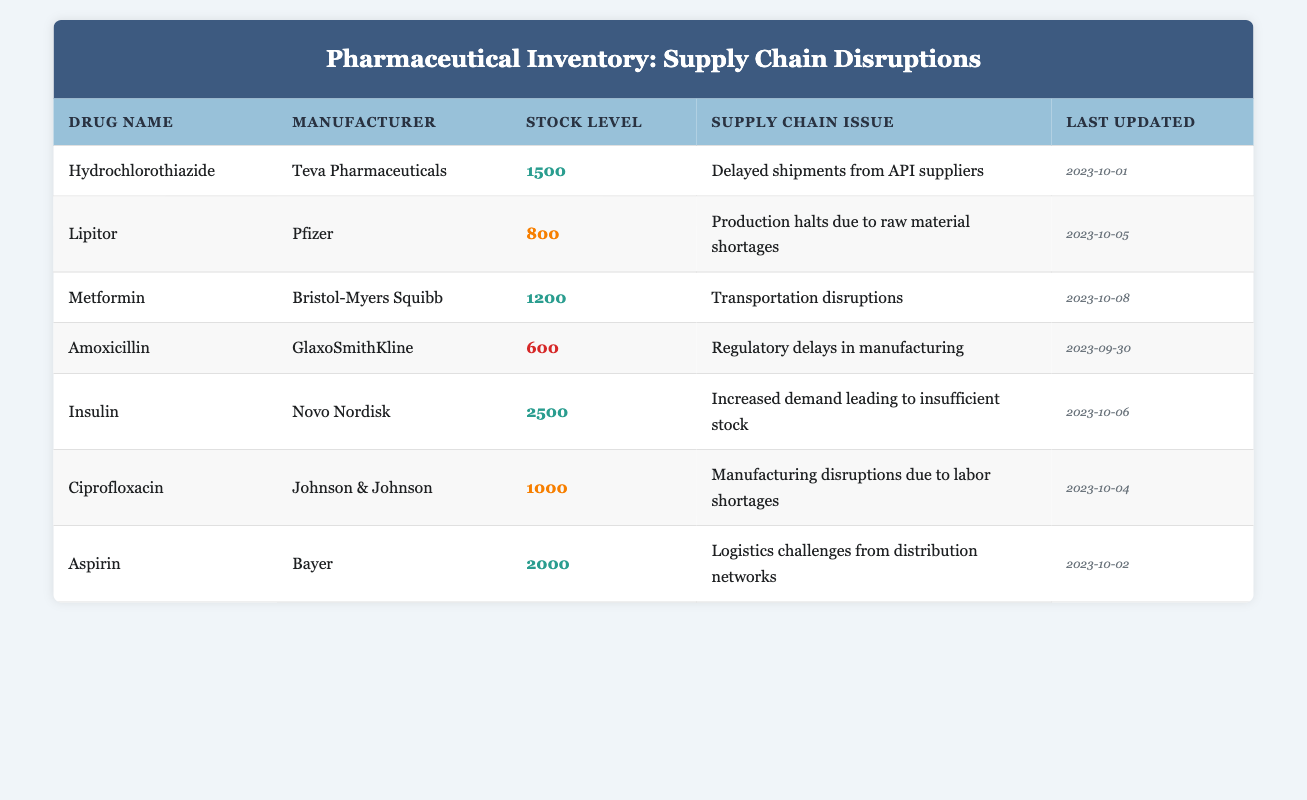What is the stock level of Metformin? The stock level of Metformin is listed in the "Stock Level" column next to the drug name "Metformin". It shows the value 1200.
Answer: 1200 Which drug has the lowest stock level? Looking through the "Stock Level" column, Amoxicillin has the lowest stock level of 600, as it's the smallest value in that column.
Answer: Amoxicillin Is there any drug that has a stock level above 2000? By checking the "Stock Level" column, Insulin has a stock level of 2500, which is above 2000.
Answer: Yes What is the total stock level of all the drugs in the inventory? To find the total stock level, we need to sum all the individual stock levels: 1500 (Hydrochlorothiazide) + 800 (Lipitor) + 1200 (Metformin) + 600 (Amoxicillin) + 2500 (Insulin) + 1000 (Ciprofloxacin) + 2000 (Aspirin) = 8600.
Answer: 8600 What supply chain issue is causing the stock level of Lipitor to be affected? Lipitor’s row in the table states the supply chain issue is "Production halts due to raw material shortages", which directly relates to its current stock challenges.
Answer: Production halts due to raw material shortages Which manufacturer has two drugs listed in the inventory, and what are those drugs? By reviewing the "Manufacturer" column, we see that Teva Pharmaceuticals has only Hydrochlorothiazide, while Novo Nordisk has only Insulin. There are no manufacturers listed with multiple drugs.
Answer: None Are there more drugs affected by labor shortages than by regulatory delays? The table shows that Ciprofloxacin is affected by labor shortages and Amoxicillin by regulatory delays. Since both issues affect only one drug each, the counts are equal.
Answer: No How many drugs have a stock level of 1000 or more? By examining the "Stock Level" column, we see that Hydrochlorothiazide (1500), Metformin (1200), Insulin (2500), Ciprofloxacin (1000), and Aspirin (2000) meet this criteria. This totals to 5 drugs.
Answer: 5 What was the last updated date for the drug with the highest stock level? The drug with the highest stock level is Insulin, which shows a last updated date of "2023-10-06" in the corresponding column.
Answer: 2023-10-06 